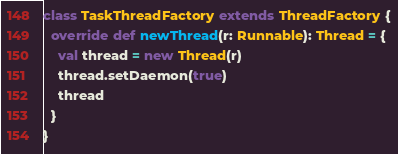<code> <loc_0><loc_0><loc_500><loc_500><_Scala_>class TaskThreadFactory extends ThreadFactory {
  override def newThread(r: Runnable): Thread = {
    val thread = new Thread(r)
    thread.setDaemon(true)
    thread
  }
}
</code> 